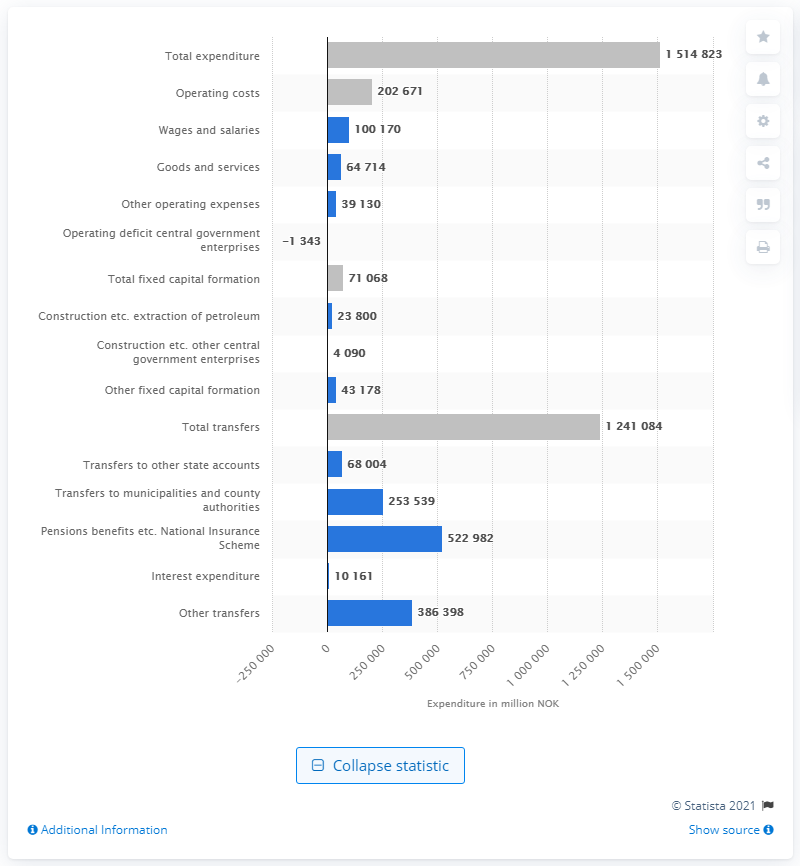List a handful of essential elements in this visual. According to the state's budget plans for 2021, it is anticipated that a total of 522982 will be spent. According to estimates, the state's operating costs in Norwegian kroner for the year 2021 were approximately 202,671... 